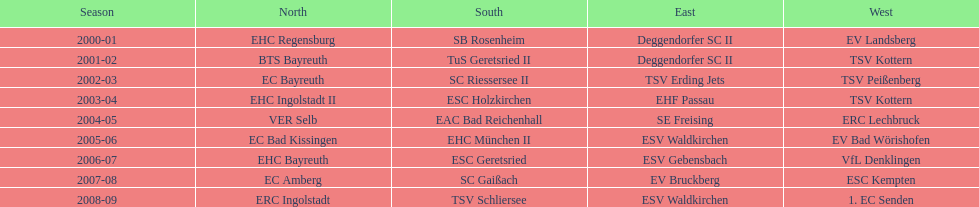How many champions are catalogued in the north? 9. 